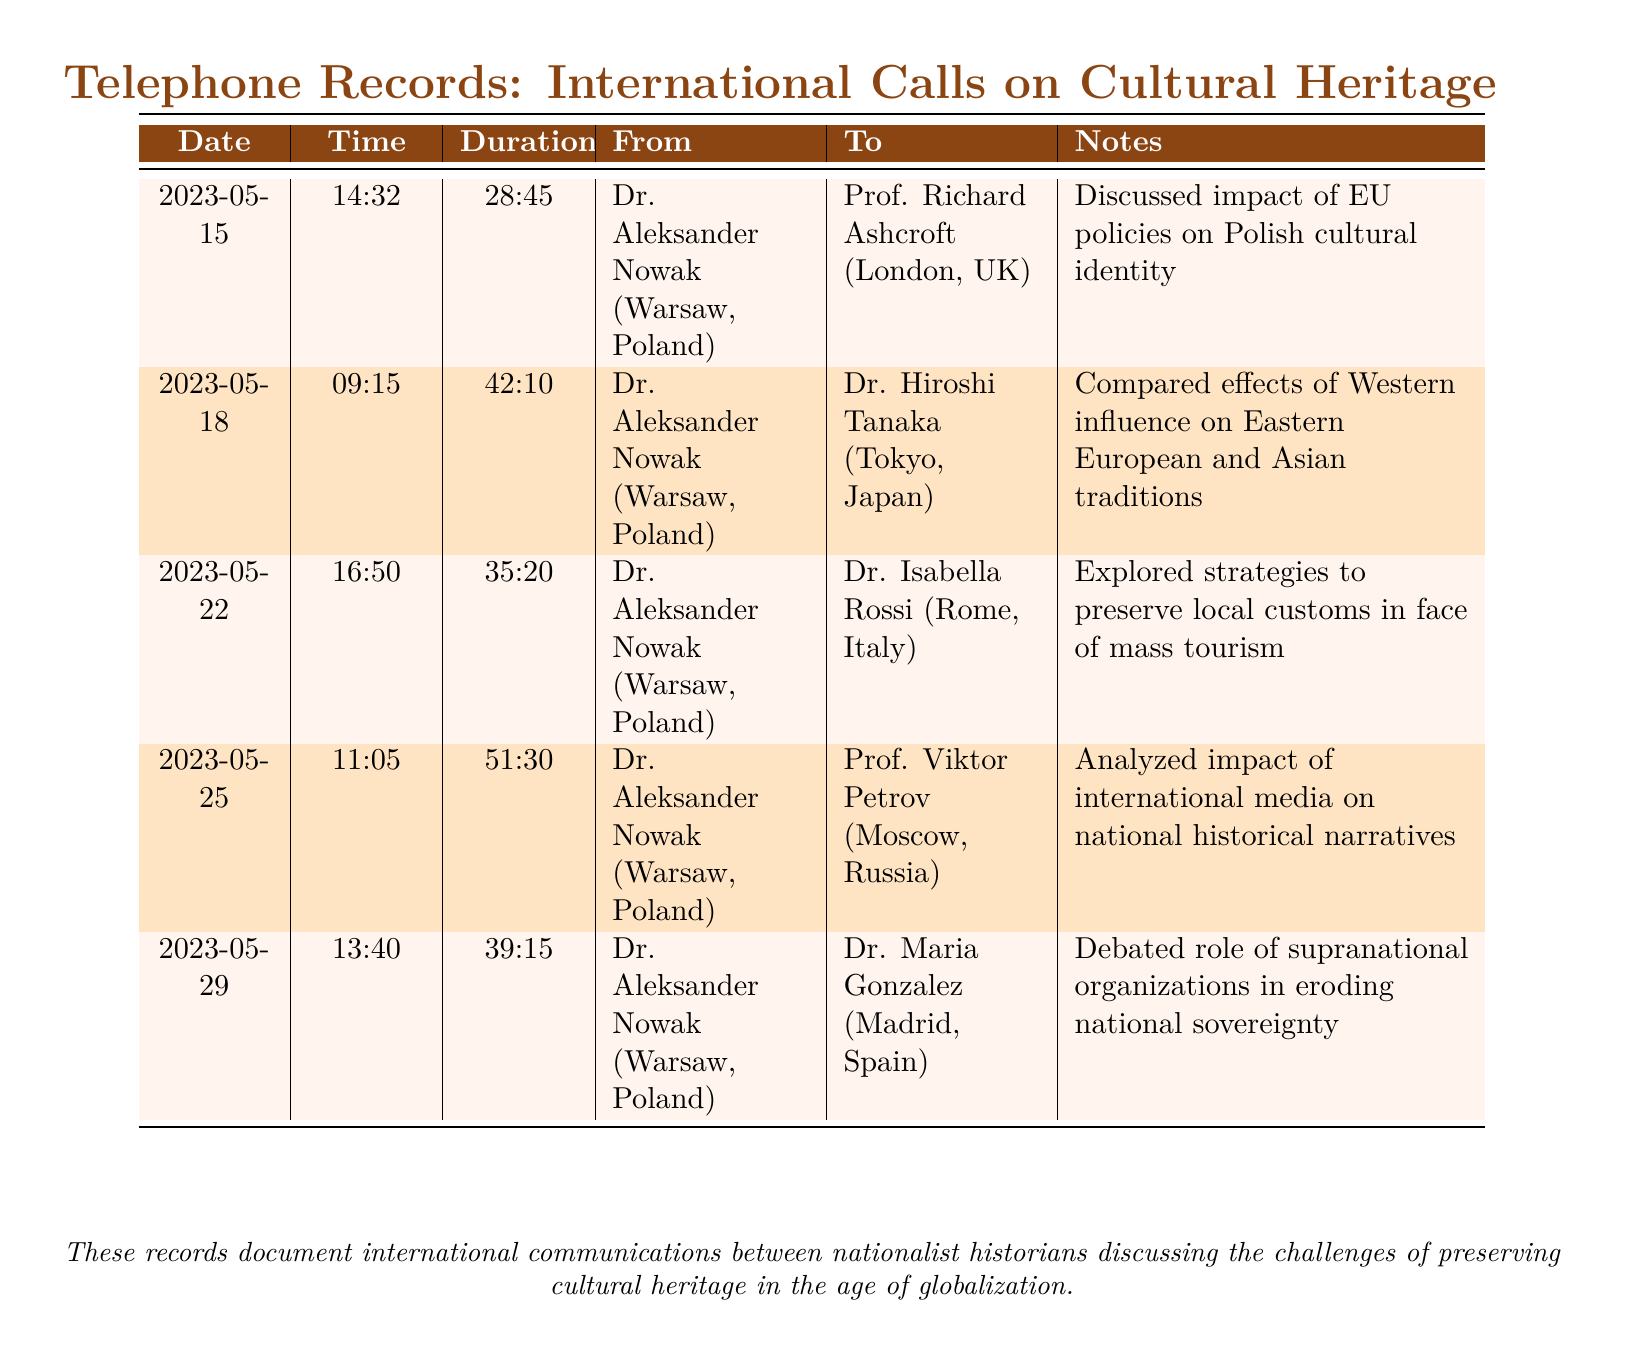what is the date of the first call? The first call is recorded on May 15, 2023.
Answer: 2023-05-15 who is the recipient of the longest call? The longest call was with Prof. Viktor Petrov.
Answer: Prof. Viktor Petrov how many minutes did the call on May 22 last? The duration of the call on May 22 is 35 minutes and 20 seconds.
Answer: 35:20 what common topic was discussed in the calls? A recurring theme in discussions was the impact of globalization on cultural heritage.
Answer: impact of globalization which historian had a conversation about the preservation of local customs? Dr. Isabella Rossi was involved in the conversation about preservation of local customs.
Answer: Dr. Isabella Rossi how many calls were made in total? The document lists a total of five calls.
Answer: 5 what was the main focus of the call with Dr. Hiroshi Tanaka? The focus was on comparing the effects of Western influence on traditions.
Answer: Western influence on traditions who initiated all the calls recorded in the document? Dr. Aleksander Nowak is listed as the caller in all instances.
Answer: Dr. Aleksander Nowak 